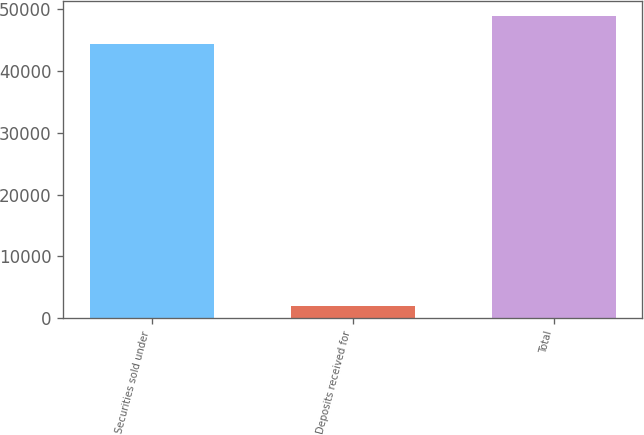Convert chart to OTSL. <chart><loc_0><loc_0><loc_500><loc_500><bar_chart><fcel>Securities sold under<fcel>Deposits received for<fcel>Total<nl><fcel>44361<fcel>1982<fcel>48797.1<nl></chart> 